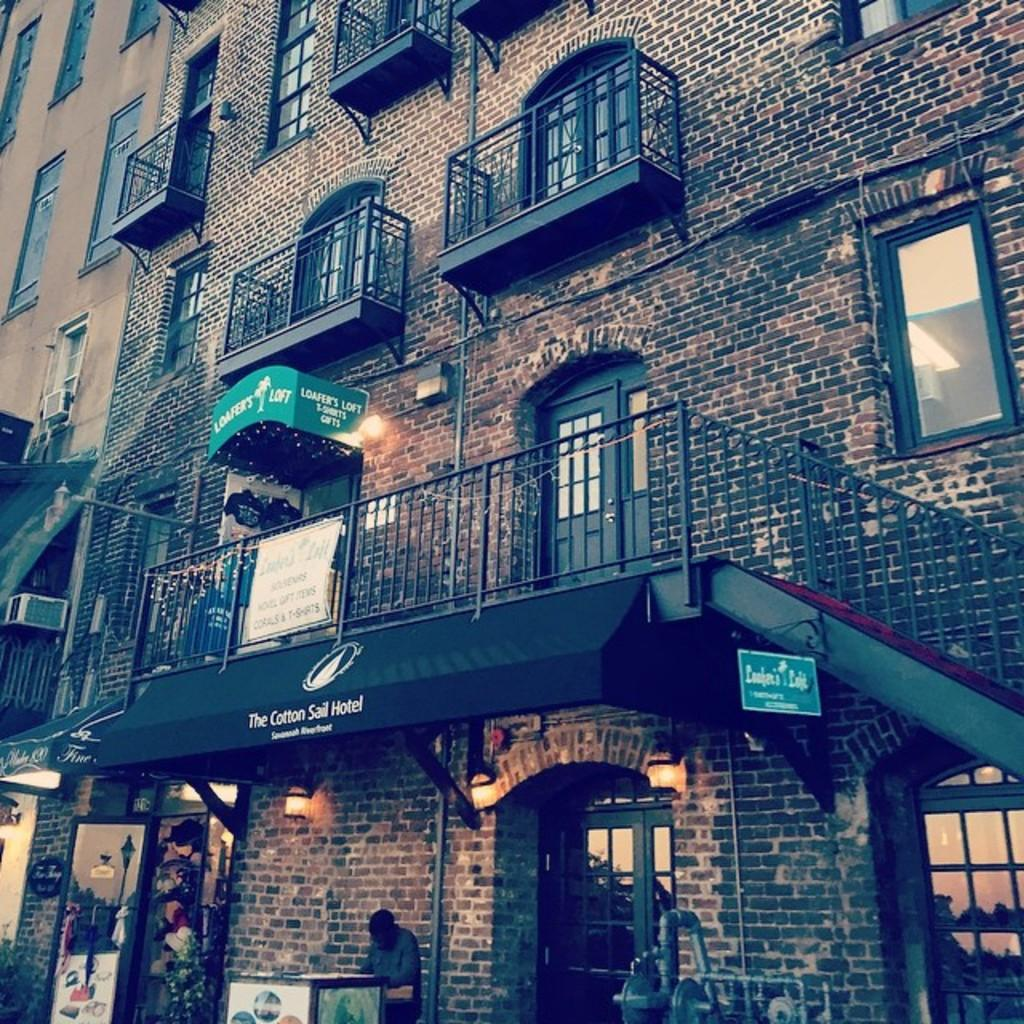What type of structure is present in the image? There is a building in the image. What features can be seen on the building? The building has windows, doors, and grills. Are there any people visible in the image? Yes, there are people visible in the image. What else can be seen in the image besides the building and people? There are lights visible in the image. What type of guitar is being played by the people in the image? There is no guitar present in the image; it only features a building, people, and lights. 